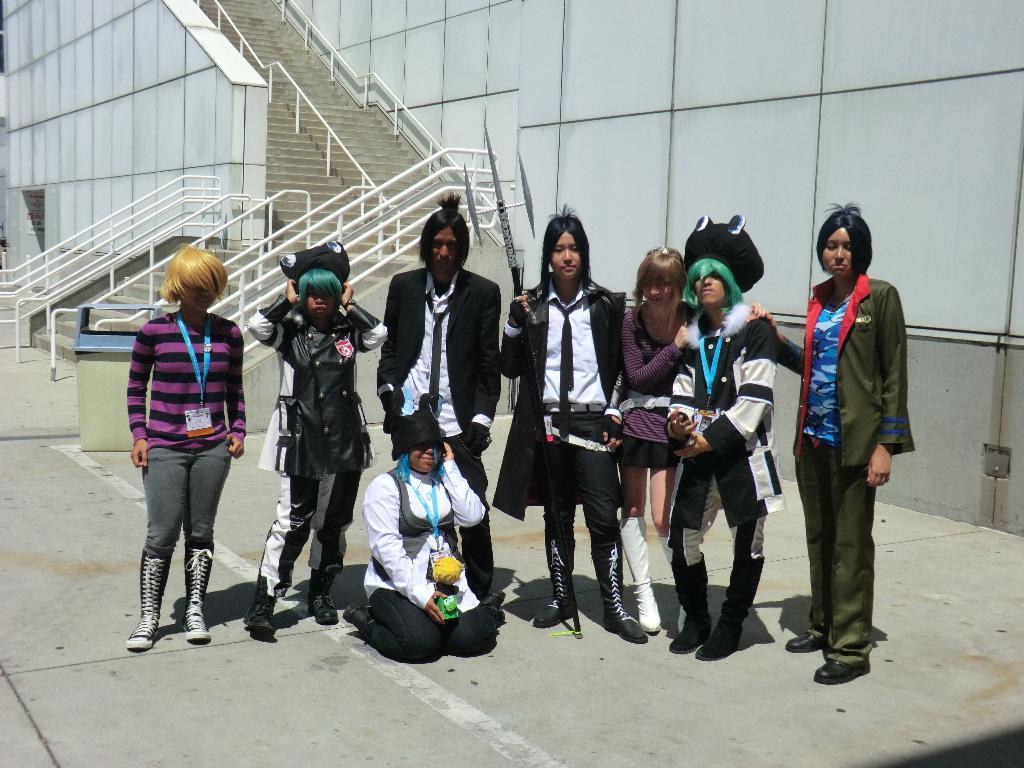Describe this image in one or two sentences. In this picture I can see a few people standing on the surface. I can see the railings and stairs. 